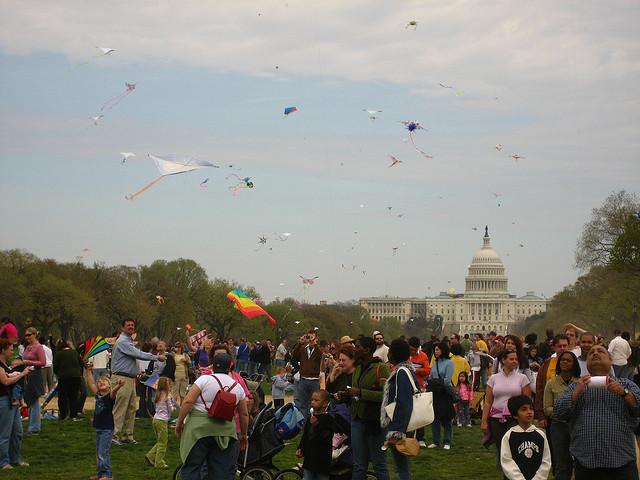What building is in the background?
Answer briefly. Capital. What is going on?
Answer briefly. Kite flying. What kind of celebration is this?
Give a very brief answer. Kite celebration. Is it a sunny day?
Keep it brief. No. What is in the sky?
Short answer required. Kites. How many buildings are behind the trees?
Keep it brief. 1. Is this in London?
Be succinct. No. 